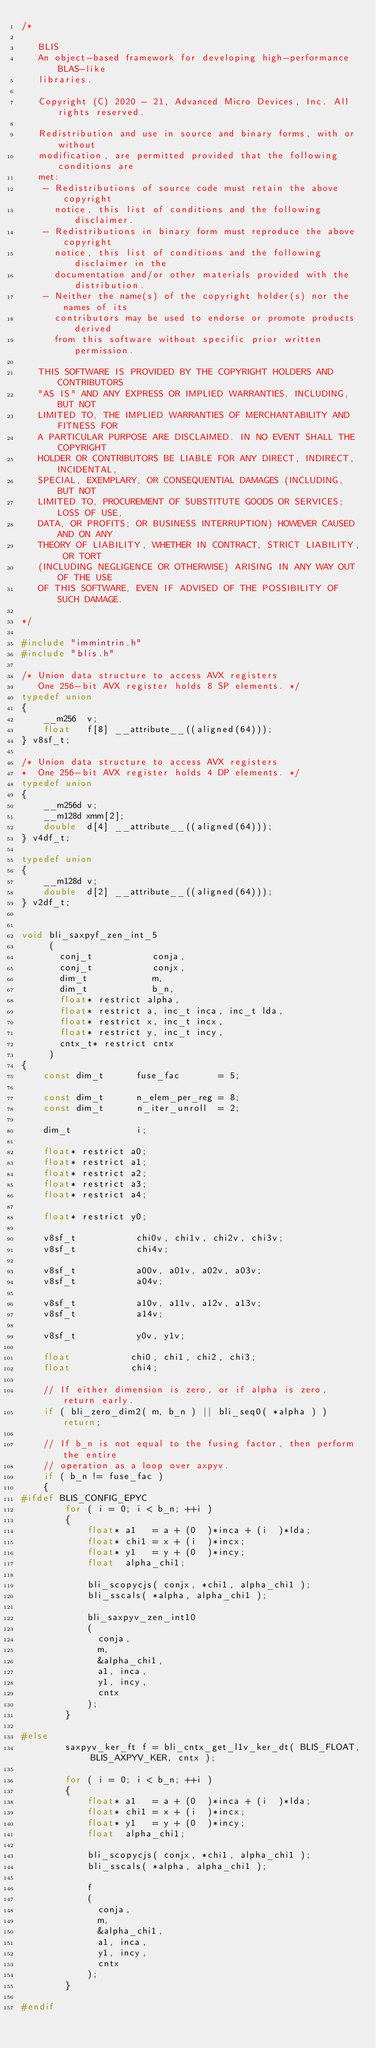Convert code to text. <code><loc_0><loc_0><loc_500><loc_500><_C_>/*

   BLIS
   An object-based framework for developing high-performance BLAS-like
   libraries.

   Copyright (C) 2020 - 21, Advanced Micro Devices, Inc. All rights reserved.

   Redistribution and use in source and binary forms, with or without
   modification, are permitted provided that the following conditions are
   met:
    - Redistributions of source code must retain the above copyright
      notice, this list of conditions and the following disclaimer.
    - Redistributions in binary form must reproduce the above copyright
      notice, this list of conditions and the following disclaimer in the
      documentation and/or other materials provided with the distribution.
    - Neither the name(s) of the copyright holder(s) nor the names of its
      contributors may be used to endorse or promote products derived
      from this software without specific prior written permission.

   THIS SOFTWARE IS PROVIDED BY THE COPYRIGHT HOLDERS AND CONTRIBUTORS
   "AS IS" AND ANY EXPRESS OR IMPLIED WARRANTIES, INCLUDING, BUT NOT
   LIMITED TO, THE IMPLIED WARRANTIES OF MERCHANTABILITY AND FITNESS FOR
   A PARTICULAR PURPOSE ARE DISCLAIMED. IN NO EVENT SHALL THE COPYRIGHT
   HOLDER OR CONTRIBUTORS BE LIABLE FOR ANY DIRECT, INDIRECT, INCIDENTAL,
   SPECIAL, EXEMPLARY, OR CONSEQUENTIAL DAMAGES (INCLUDING, BUT NOT
   LIMITED TO, PROCUREMENT OF SUBSTITUTE GOODS OR SERVICES; LOSS OF USE,
   DATA, OR PROFITS; OR BUSINESS INTERRUPTION) HOWEVER CAUSED AND ON ANY
   THEORY OF LIABILITY, WHETHER IN CONTRACT, STRICT LIABILITY, OR TORT
   (INCLUDING NEGLIGENCE OR OTHERWISE) ARISING IN ANY WAY OUT OF THE USE
   OF THIS SOFTWARE, EVEN IF ADVISED OF THE POSSIBILITY OF SUCH DAMAGE.

*/

#include "immintrin.h"
#include "blis.h"

/* Union data structure to access AVX registers
   One 256-bit AVX register holds 8 SP elements. */
typedef union
{
    __m256  v;
    float   f[8] __attribute__((aligned(64)));
} v8sf_t;

/* Union data structure to access AVX registers
*  One 256-bit AVX register holds 4 DP elements. */
typedef union
{
    __m256d v;
    __m128d xmm[2];
    double  d[4] __attribute__((aligned(64)));
} v4df_t;

typedef union
{
    __m128d v;
    double  d[2] __attribute__((aligned(64)));
} v2df_t;


void bli_saxpyf_zen_int_5
     (
       conj_t           conja,
       conj_t           conjx,
       dim_t            m,
       dim_t            b_n,
       float* restrict alpha,
       float* restrict a, inc_t inca, inc_t lda,
       float* restrict x, inc_t incx,
       float* restrict y, inc_t incy,
       cntx_t* restrict cntx
     )
{
    const dim_t      fuse_fac       = 5;

    const dim_t      n_elem_per_reg = 8;
    const dim_t      n_iter_unroll  = 2;

    dim_t            i;

    float* restrict a0;
    float* restrict a1;
    float* restrict a2;
    float* restrict a3;
    float* restrict a4;

    float* restrict y0;

    v8sf_t           chi0v, chi1v, chi2v, chi3v;
    v8sf_t           chi4v;

    v8sf_t           a00v, a01v, a02v, a03v;
    v8sf_t           a04v;

    v8sf_t           a10v, a11v, a12v, a13v;
    v8sf_t           a14v;

    v8sf_t           y0v, y1v;

    float           chi0, chi1, chi2, chi3;
    float           chi4;

    // If either dimension is zero, or if alpha is zero, return early.
    if ( bli_zero_dim2( m, b_n ) || bli_seq0( *alpha ) ) return;

    // If b_n is not equal to the fusing factor, then perform the entire
    // operation as a loop over axpyv.
    if ( b_n != fuse_fac )
    {
#ifdef BLIS_CONFIG_EPYC
        for ( i = 0; i < b_n; ++i )
        {
            float* a1   = a + (0  )*inca + (i  )*lda;
            float* chi1 = x + (i  )*incx;
            float* y1   = y + (0  )*incy;
            float  alpha_chi1;

            bli_scopycjs( conjx, *chi1, alpha_chi1 );
            bli_sscals( *alpha, alpha_chi1 );

            bli_saxpyv_zen_int10
            (
              conja,
              m,
              &alpha_chi1,
              a1, inca,
              y1, incy,
              cntx
            );
        }

#else
        saxpyv_ker_ft f = bli_cntx_get_l1v_ker_dt( BLIS_FLOAT, BLIS_AXPYV_KER, cntx );

        for ( i = 0; i < b_n; ++i )
        {
            float* a1   = a + (0  )*inca + (i  )*lda;
            float* chi1 = x + (i  )*incx;
            float* y1   = y + (0  )*incy;
            float  alpha_chi1;

            bli_scopycjs( conjx, *chi1, alpha_chi1 );
            bli_sscals( *alpha, alpha_chi1 );

            f
            (
              conja,
              m,
              &alpha_chi1,
              a1, inca,
              y1, incy,
              cntx
            );
        }

#endif</code> 